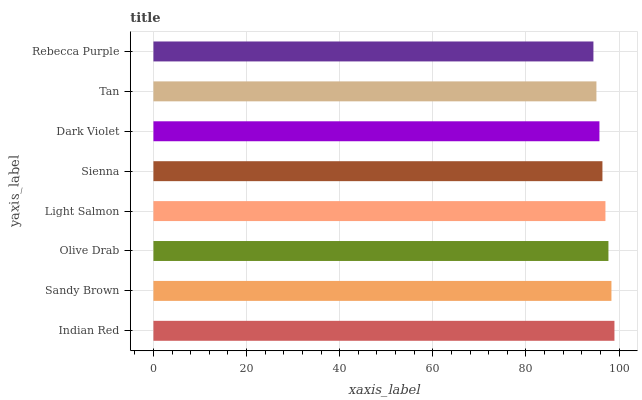Is Rebecca Purple the minimum?
Answer yes or no. Yes. Is Indian Red the maximum?
Answer yes or no. Yes. Is Sandy Brown the minimum?
Answer yes or no. No. Is Sandy Brown the maximum?
Answer yes or no. No. Is Indian Red greater than Sandy Brown?
Answer yes or no. Yes. Is Sandy Brown less than Indian Red?
Answer yes or no. Yes. Is Sandy Brown greater than Indian Red?
Answer yes or no. No. Is Indian Red less than Sandy Brown?
Answer yes or no. No. Is Light Salmon the high median?
Answer yes or no. Yes. Is Sienna the low median?
Answer yes or no. Yes. Is Sandy Brown the high median?
Answer yes or no. No. Is Sandy Brown the low median?
Answer yes or no. No. 